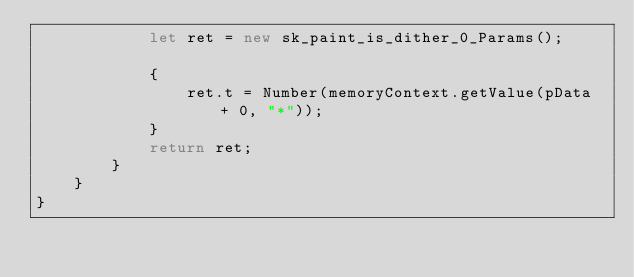<code> <loc_0><loc_0><loc_500><loc_500><_TypeScript_>			let ret = new sk_paint_is_dither_0_Params();
			
			{
				ret.t = Number(memoryContext.getValue(pData + 0, "*"));
			}
			return ret;
		}
	}
}
</code> 